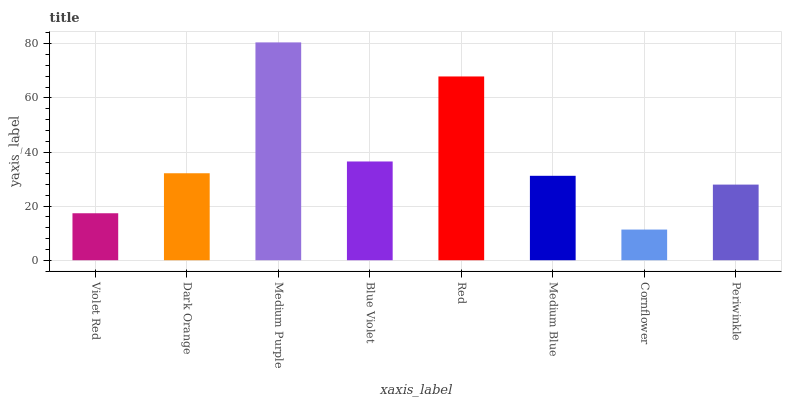Is Cornflower the minimum?
Answer yes or no. Yes. Is Medium Purple the maximum?
Answer yes or no. Yes. Is Dark Orange the minimum?
Answer yes or no. No. Is Dark Orange the maximum?
Answer yes or no. No. Is Dark Orange greater than Violet Red?
Answer yes or no. Yes. Is Violet Red less than Dark Orange?
Answer yes or no. Yes. Is Violet Red greater than Dark Orange?
Answer yes or no. No. Is Dark Orange less than Violet Red?
Answer yes or no. No. Is Dark Orange the high median?
Answer yes or no. Yes. Is Medium Blue the low median?
Answer yes or no. Yes. Is Blue Violet the high median?
Answer yes or no. No. Is Medium Purple the low median?
Answer yes or no. No. 